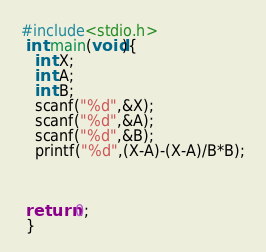Convert code to text. <code><loc_0><loc_0><loc_500><loc_500><_C++_>#include<stdio.h>
 int main(void){
   int X;
   int A;
   int B;
   scanf("%d",&X);
   scanf("%d",&A);
   scanf("%d",&B);
   printf("%d",(X-A)-(X-A)/B*B);
   
 
 
 return 0;
 }</code> 